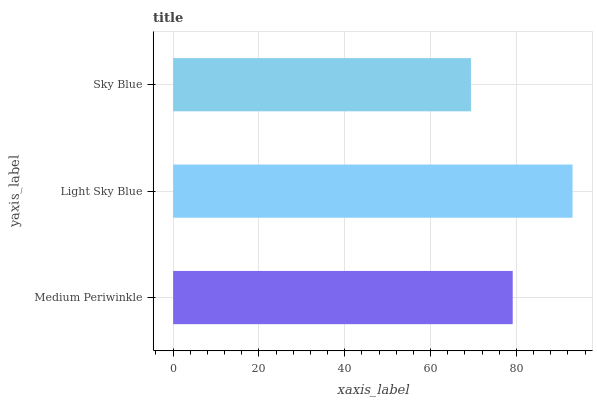Is Sky Blue the minimum?
Answer yes or no. Yes. Is Light Sky Blue the maximum?
Answer yes or no. Yes. Is Light Sky Blue the minimum?
Answer yes or no. No. Is Sky Blue the maximum?
Answer yes or no. No. Is Light Sky Blue greater than Sky Blue?
Answer yes or no. Yes. Is Sky Blue less than Light Sky Blue?
Answer yes or no. Yes. Is Sky Blue greater than Light Sky Blue?
Answer yes or no. No. Is Light Sky Blue less than Sky Blue?
Answer yes or no. No. Is Medium Periwinkle the high median?
Answer yes or no. Yes. Is Medium Periwinkle the low median?
Answer yes or no. Yes. Is Light Sky Blue the high median?
Answer yes or no. No. Is Sky Blue the low median?
Answer yes or no. No. 